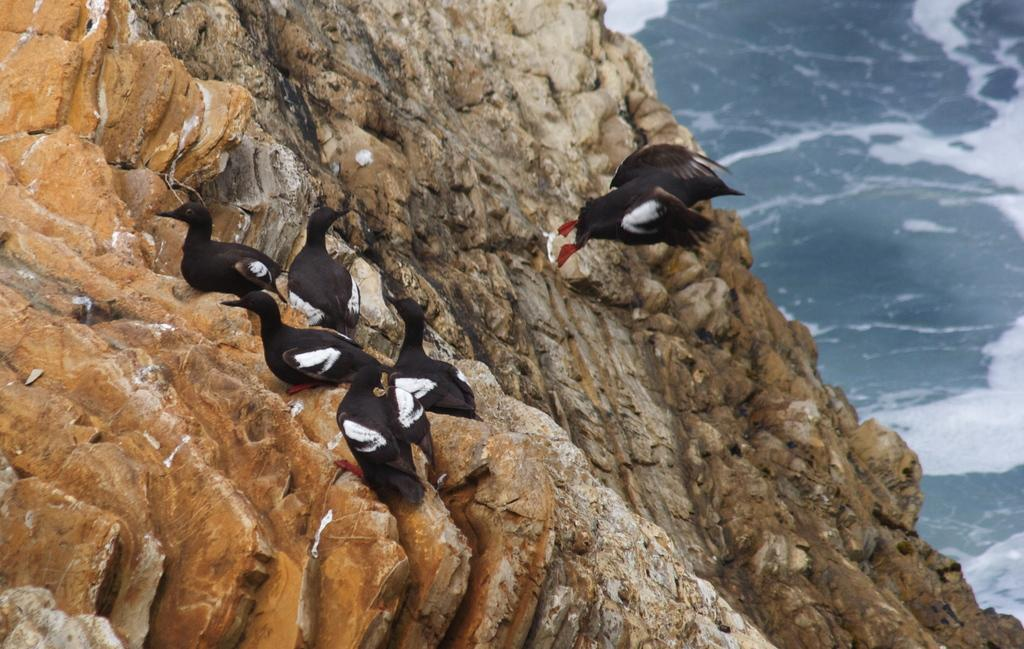What type of animals can be seen in the image? There are birds in the image. What colors are the birds in the image? The color of the birds is black and white. What does the caption on the sheet say about the rabbits in the image? There is no sheet or caption present in the image, and there are no rabbits mentioned in the facts provided. 